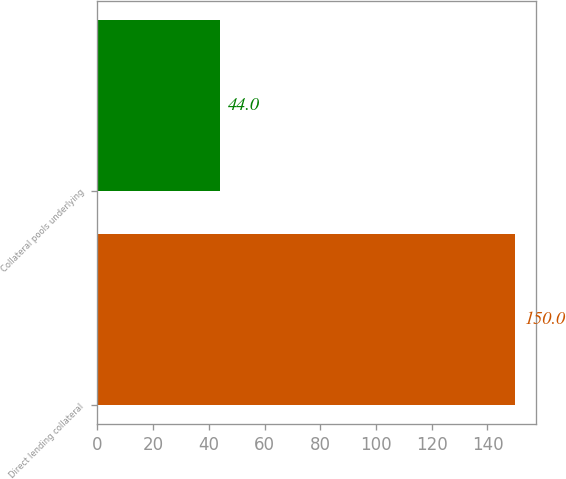Convert chart. <chart><loc_0><loc_0><loc_500><loc_500><bar_chart><fcel>Direct lending collateral<fcel>Collateral pools underlying<nl><fcel>150<fcel>44<nl></chart> 